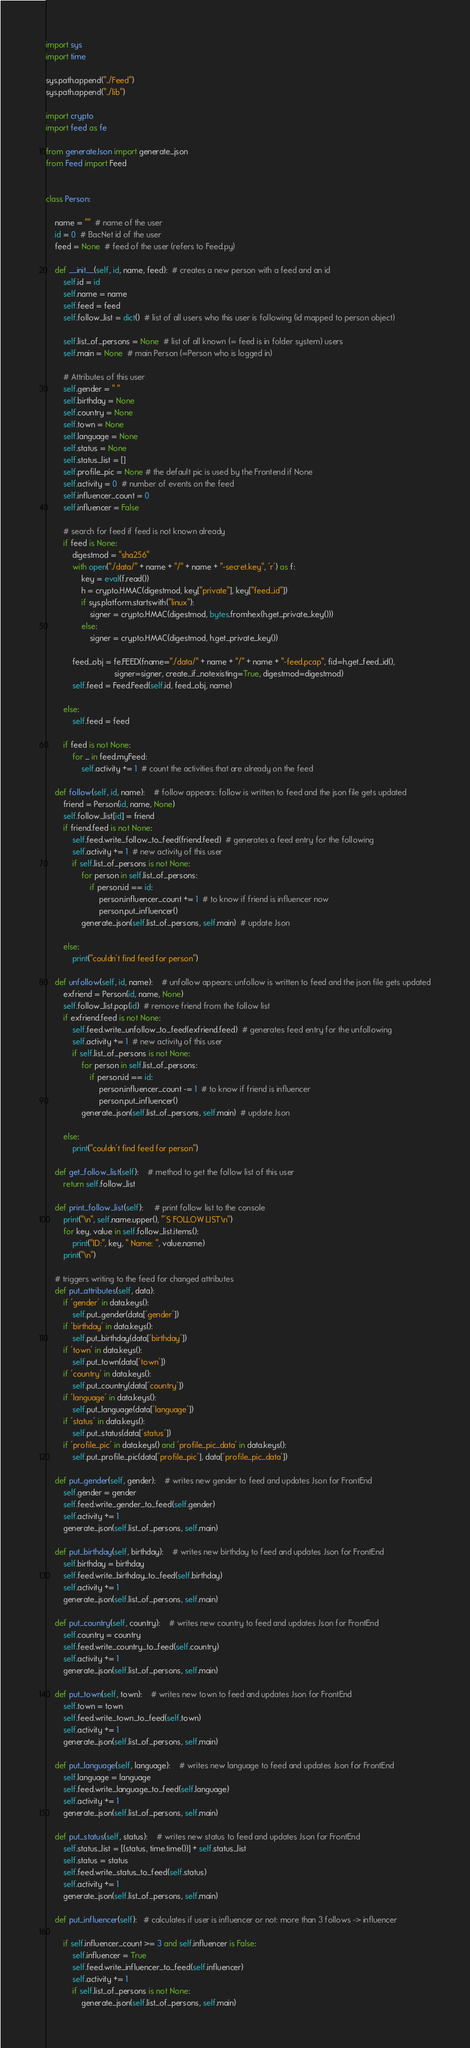<code> <loc_0><loc_0><loc_500><loc_500><_Python_>import sys
import time

sys.path.append("../Feed")
sys.path.append("../lib")

import crypto
import feed as fe

from generateJson import generate_json
from Feed import Feed


class Person:

    name = ""  # name of the user
    id = 0  # BacNet id of the user
    feed = None  # feed of the user (refers to Feed.py)

    def __init__(self, id, name, feed):  # creates a new person with a feed and an id
        self.id = id
        self.name = name
        self.feed = feed
        self.follow_list = dict()  # list of all users who this user is following (id mapped to person object)

        self.list_of_persons = None  # list of all known (= feed is in folder system) users
        self.main = None  # main Person (=Person who is logged in)

        # Attributes of this user
        self.gender = " "
        self.birthday = None
        self.country = None
        self.town = None
        self.language = None
        self.status = None
        self.status_list = []
        self.profile_pic = None # the default pic is used by the Frontend if None
        self.activity = 0  # number of events on the feed
        self.influencer_count = 0
        self.influencer = False

        # search for feed if feed is not known already
        if feed is None:
            digestmod = "sha256"
            with open("./data/" + name + "/" + name + "-secret.key", 'r') as f:
                key = eval(f.read())
                h = crypto.HMAC(digestmod, key["private"], key["feed_id"])
                if sys.platform.startswith("linux"):
                    signer = crypto.HMAC(digestmod, bytes.fromhex(h.get_private_key()))
                else:
                    signer = crypto.HMAC(digestmod, h.get_private_key())

            feed_obj = fe.FEED(fname="./data/" + name + "/" + name + "-feed.pcap", fid=h.get_feed_id(),
                               signer=signer, create_if_notexisting=True, digestmod=digestmod)
            self.feed = Feed.Feed(self.id, feed_obj, name)

        else:
            self.feed = feed

        if feed is not None:
            for _ in feed.myFeed:
                self.activity += 1  # count the activities that are already on the feed

    def follow(self, id, name):    # follow appears: follow is written to feed and the json file gets updated
        friend = Person(id, name, None)
        self.follow_list[id] = friend
        if friend.feed is not None:
            self.feed.write_follow_to_feed(friend.feed)  # generates a feed entry for the following
            self.activity += 1  # new activity of this user
            if self.list_of_persons is not None:
                for person in self.list_of_persons:
                    if person.id == id:
                        person.influencer_count += 1  # to know if friend is influencer now
                        person.put_influencer()
                generate_json(self.list_of_persons, self.main)  # update Json

        else:
            print("couldn't find feed for person")

    def unfollow(self, id, name):    # unfollow appears: unfollow is written to feed and the json file gets updated
        exfriend = Person(id, name, None)
        self.follow_list.pop(id)  # remove friend from the follow list
        if exfriend.feed is not None:
            self.feed.write_unfollow_to_feed(exfriend.feed)  # generates feed entry for the unfollowing
            self.activity += 1  # new activity of this user
            if self.list_of_persons is not None:
                for person in self.list_of_persons:
                    if person.id == id:
                        person.influencer_count -= 1  # to know if friend is influencer
                        person.put_influencer()
                generate_json(self.list_of_persons, self.main)  # update Json

        else:
            print("couldn't find feed for person")

    def get_follow_list(self):    # method to get the follow list of this user
        return self.follow_list

    def print_follow_list(self):     # print follow list to the console
        print("\n", self.name.upper(), "'S FOLLOW LIST\n")
        for key, value in self.follow_list.items():
            print("ID:", key, " Name: ", value.name)
        print("\n")

    # triggers writing to the feed for changed attributes
    def put_attributes(self, data):
        if 'gender' in data.keys():
            self.put_gender(data['gender'])
        if 'birthday' in data.keys():
            self.put_birthday(data['birthday'])
        if 'town' in data.keys():
            self.put_town(data['town'])
        if 'country' in data.keys():
            self.put_country(data['country'])
        if 'language' in data.keys():
            self.put_language(data['language'])
        if 'status' in data.keys():
            self.put_status(data['status'])
        if 'profile_pic' in data.keys() and 'profile_pic_data' in data.keys():
            self.put_profile_pic(data['profile_pic'], data['profile_pic_data'])

    def put_gender(self, gender):    # writes new gender to feed and updates Json for FrontEnd
        self.gender = gender
        self.feed.write_gender_to_feed(self.gender)
        self.activity += 1
        generate_json(self.list_of_persons, self.main)

    def put_birthday(self, birthday):    # writes new birthday to feed and updates Json for FrontEnd
        self.birthday = birthday
        self.feed.write_birthday_to_feed(self.birthday)
        self.activity += 1
        generate_json(self.list_of_persons, self.main)

    def put_country(self, country):    # writes new country to feed and updates Json for FrontEnd
        self.country = country
        self.feed.write_country_to_feed(self.country)
        self.activity += 1
        generate_json(self.list_of_persons, self.main)

    def put_town(self, town):    # writes new town to feed and updates Json for FrontEnd
        self.town = town
        self.feed.write_town_to_feed(self.town)
        self.activity += 1
        generate_json(self.list_of_persons, self.main)

    def put_language(self, language):    # writes new language to feed and updates Json for FrontEnd
        self.language = language
        self.feed.write_language_to_feed(self.language)
        self.activity += 1
        generate_json(self.list_of_persons, self.main)

    def put_status(self, status):    # writes new status to feed and updates Json for FrontEnd
        self.status_list = [(status, time.time())] + self.status_list
        self.status = status
        self.feed.write_status_to_feed(self.status)
        self.activity += 1
        generate_json(self.list_of_persons, self.main)

    def put_influencer(self):   # calculates if user is influencer or not: more than 3 follows -> influencer

        if self.influencer_count >= 3 and self.influencer is False:
            self.influencer = True
            self.feed.write_influencer_to_feed(self.influencer)
            self.activity += 1
            if self.list_of_persons is not None:
                generate_json(self.list_of_persons, self.main)
</code> 